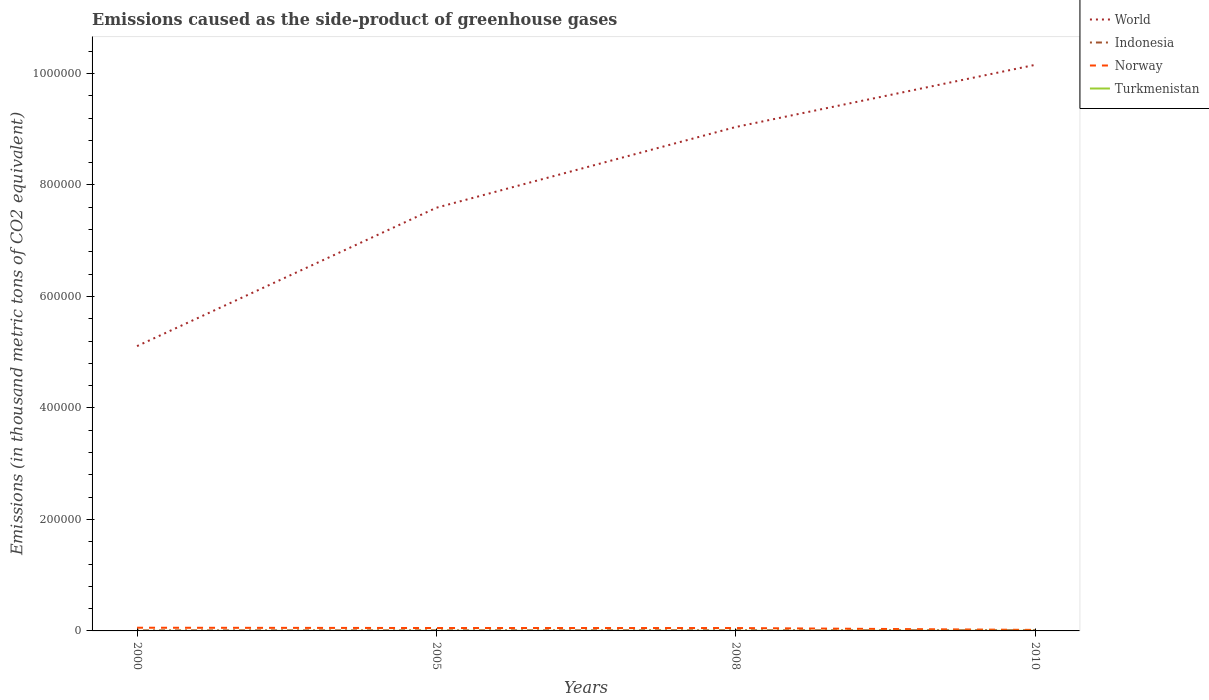Does the line corresponding to Norway intersect with the line corresponding to Turkmenistan?
Offer a very short reply. No. Is the number of lines equal to the number of legend labels?
Provide a short and direct response. Yes. Across all years, what is the maximum emissions caused as the side-product of greenhouse gases in Indonesia?
Make the answer very short. 997.4. In which year was the emissions caused as the side-product of greenhouse gases in Indonesia maximum?
Your response must be concise. 2000. What is the total emissions caused as the side-product of greenhouse gases in Norway in the graph?
Provide a short and direct response. 524.3. What is the difference between the highest and the second highest emissions caused as the side-product of greenhouse gases in Turkmenistan?
Give a very brief answer. 128.1. What is the difference between the highest and the lowest emissions caused as the side-product of greenhouse gases in World?
Your answer should be compact. 2. Is the emissions caused as the side-product of greenhouse gases in World strictly greater than the emissions caused as the side-product of greenhouse gases in Norway over the years?
Make the answer very short. No. Where does the legend appear in the graph?
Your answer should be very brief. Top right. What is the title of the graph?
Your response must be concise. Emissions caused as the side-product of greenhouse gases. What is the label or title of the X-axis?
Provide a succinct answer. Years. What is the label or title of the Y-axis?
Your response must be concise. Emissions (in thousand metric tons of CO2 equivalent). What is the Emissions (in thousand metric tons of CO2 equivalent) of World in 2000?
Offer a terse response. 5.11e+05. What is the Emissions (in thousand metric tons of CO2 equivalent) in Indonesia in 2000?
Your answer should be compact. 997.4. What is the Emissions (in thousand metric tons of CO2 equivalent) in Norway in 2000?
Offer a very short reply. 5742.8. What is the Emissions (in thousand metric tons of CO2 equivalent) of Turkmenistan in 2000?
Your answer should be compact. 10.9. What is the Emissions (in thousand metric tons of CO2 equivalent) of World in 2005?
Your answer should be compact. 7.59e+05. What is the Emissions (in thousand metric tons of CO2 equivalent) of Indonesia in 2005?
Provide a succinct answer. 1020.5. What is the Emissions (in thousand metric tons of CO2 equivalent) in Norway in 2005?
Offer a very short reply. 5218.5. What is the Emissions (in thousand metric tons of CO2 equivalent) of Turkmenistan in 2005?
Ensure brevity in your answer.  72.9. What is the Emissions (in thousand metric tons of CO2 equivalent) of World in 2008?
Your answer should be very brief. 9.04e+05. What is the Emissions (in thousand metric tons of CO2 equivalent) of Indonesia in 2008?
Offer a terse response. 1146. What is the Emissions (in thousand metric tons of CO2 equivalent) in Norway in 2008?
Offer a terse response. 5179.9. What is the Emissions (in thousand metric tons of CO2 equivalent) in Turkmenistan in 2008?
Your answer should be compact. 112.2. What is the Emissions (in thousand metric tons of CO2 equivalent) of World in 2010?
Keep it short and to the point. 1.02e+06. What is the Emissions (in thousand metric tons of CO2 equivalent) in Indonesia in 2010?
Ensure brevity in your answer.  1241. What is the Emissions (in thousand metric tons of CO2 equivalent) of Norway in 2010?
Your answer should be very brief. 1823. What is the Emissions (in thousand metric tons of CO2 equivalent) in Turkmenistan in 2010?
Your answer should be compact. 139. Across all years, what is the maximum Emissions (in thousand metric tons of CO2 equivalent) in World?
Give a very brief answer. 1.02e+06. Across all years, what is the maximum Emissions (in thousand metric tons of CO2 equivalent) in Indonesia?
Offer a terse response. 1241. Across all years, what is the maximum Emissions (in thousand metric tons of CO2 equivalent) of Norway?
Your response must be concise. 5742.8. Across all years, what is the maximum Emissions (in thousand metric tons of CO2 equivalent) in Turkmenistan?
Provide a short and direct response. 139. Across all years, what is the minimum Emissions (in thousand metric tons of CO2 equivalent) of World?
Keep it short and to the point. 5.11e+05. Across all years, what is the minimum Emissions (in thousand metric tons of CO2 equivalent) of Indonesia?
Provide a succinct answer. 997.4. Across all years, what is the minimum Emissions (in thousand metric tons of CO2 equivalent) in Norway?
Your answer should be very brief. 1823. Across all years, what is the minimum Emissions (in thousand metric tons of CO2 equivalent) in Turkmenistan?
Provide a succinct answer. 10.9. What is the total Emissions (in thousand metric tons of CO2 equivalent) of World in the graph?
Offer a very short reply. 3.19e+06. What is the total Emissions (in thousand metric tons of CO2 equivalent) in Indonesia in the graph?
Keep it short and to the point. 4404.9. What is the total Emissions (in thousand metric tons of CO2 equivalent) in Norway in the graph?
Provide a succinct answer. 1.80e+04. What is the total Emissions (in thousand metric tons of CO2 equivalent) of Turkmenistan in the graph?
Keep it short and to the point. 335. What is the difference between the Emissions (in thousand metric tons of CO2 equivalent) of World in 2000 and that in 2005?
Provide a short and direct response. -2.48e+05. What is the difference between the Emissions (in thousand metric tons of CO2 equivalent) in Indonesia in 2000 and that in 2005?
Offer a very short reply. -23.1. What is the difference between the Emissions (in thousand metric tons of CO2 equivalent) in Norway in 2000 and that in 2005?
Provide a short and direct response. 524.3. What is the difference between the Emissions (in thousand metric tons of CO2 equivalent) in Turkmenistan in 2000 and that in 2005?
Make the answer very short. -62. What is the difference between the Emissions (in thousand metric tons of CO2 equivalent) of World in 2000 and that in 2008?
Give a very brief answer. -3.93e+05. What is the difference between the Emissions (in thousand metric tons of CO2 equivalent) of Indonesia in 2000 and that in 2008?
Your response must be concise. -148.6. What is the difference between the Emissions (in thousand metric tons of CO2 equivalent) in Norway in 2000 and that in 2008?
Offer a terse response. 562.9. What is the difference between the Emissions (in thousand metric tons of CO2 equivalent) in Turkmenistan in 2000 and that in 2008?
Give a very brief answer. -101.3. What is the difference between the Emissions (in thousand metric tons of CO2 equivalent) of World in 2000 and that in 2010?
Make the answer very short. -5.05e+05. What is the difference between the Emissions (in thousand metric tons of CO2 equivalent) in Indonesia in 2000 and that in 2010?
Provide a short and direct response. -243.6. What is the difference between the Emissions (in thousand metric tons of CO2 equivalent) in Norway in 2000 and that in 2010?
Give a very brief answer. 3919.8. What is the difference between the Emissions (in thousand metric tons of CO2 equivalent) of Turkmenistan in 2000 and that in 2010?
Your response must be concise. -128.1. What is the difference between the Emissions (in thousand metric tons of CO2 equivalent) in World in 2005 and that in 2008?
Offer a very short reply. -1.45e+05. What is the difference between the Emissions (in thousand metric tons of CO2 equivalent) of Indonesia in 2005 and that in 2008?
Give a very brief answer. -125.5. What is the difference between the Emissions (in thousand metric tons of CO2 equivalent) of Norway in 2005 and that in 2008?
Ensure brevity in your answer.  38.6. What is the difference between the Emissions (in thousand metric tons of CO2 equivalent) in Turkmenistan in 2005 and that in 2008?
Make the answer very short. -39.3. What is the difference between the Emissions (in thousand metric tons of CO2 equivalent) in World in 2005 and that in 2010?
Give a very brief answer. -2.56e+05. What is the difference between the Emissions (in thousand metric tons of CO2 equivalent) of Indonesia in 2005 and that in 2010?
Offer a terse response. -220.5. What is the difference between the Emissions (in thousand metric tons of CO2 equivalent) of Norway in 2005 and that in 2010?
Ensure brevity in your answer.  3395.5. What is the difference between the Emissions (in thousand metric tons of CO2 equivalent) of Turkmenistan in 2005 and that in 2010?
Ensure brevity in your answer.  -66.1. What is the difference between the Emissions (in thousand metric tons of CO2 equivalent) in World in 2008 and that in 2010?
Provide a short and direct response. -1.11e+05. What is the difference between the Emissions (in thousand metric tons of CO2 equivalent) of Indonesia in 2008 and that in 2010?
Your answer should be compact. -95. What is the difference between the Emissions (in thousand metric tons of CO2 equivalent) of Norway in 2008 and that in 2010?
Your answer should be compact. 3356.9. What is the difference between the Emissions (in thousand metric tons of CO2 equivalent) in Turkmenistan in 2008 and that in 2010?
Provide a succinct answer. -26.8. What is the difference between the Emissions (in thousand metric tons of CO2 equivalent) in World in 2000 and the Emissions (in thousand metric tons of CO2 equivalent) in Indonesia in 2005?
Offer a very short reply. 5.10e+05. What is the difference between the Emissions (in thousand metric tons of CO2 equivalent) of World in 2000 and the Emissions (in thousand metric tons of CO2 equivalent) of Norway in 2005?
Provide a succinct answer. 5.06e+05. What is the difference between the Emissions (in thousand metric tons of CO2 equivalent) of World in 2000 and the Emissions (in thousand metric tons of CO2 equivalent) of Turkmenistan in 2005?
Offer a very short reply. 5.11e+05. What is the difference between the Emissions (in thousand metric tons of CO2 equivalent) in Indonesia in 2000 and the Emissions (in thousand metric tons of CO2 equivalent) in Norway in 2005?
Ensure brevity in your answer.  -4221.1. What is the difference between the Emissions (in thousand metric tons of CO2 equivalent) of Indonesia in 2000 and the Emissions (in thousand metric tons of CO2 equivalent) of Turkmenistan in 2005?
Offer a terse response. 924.5. What is the difference between the Emissions (in thousand metric tons of CO2 equivalent) of Norway in 2000 and the Emissions (in thousand metric tons of CO2 equivalent) of Turkmenistan in 2005?
Keep it short and to the point. 5669.9. What is the difference between the Emissions (in thousand metric tons of CO2 equivalent) in World in 2000 and the Emissions (in thousand metric tons of CO2 equivalent) in Indonesia in 2008?
Make the answer very short. 5.10e+05. What is the difference between the Emissions (in thousand metric tons of CO2 equivalent) of World in 2000 and the Emissions (in thousand metric tons of CO2 equivalent) of Norway in 2008?
Give a very brief answer. 5.06e+05. What is the difference between the Emissions (in thousand metric tons of CO2 equivalent) in World in 2000 and the Emissions (in thousand metric tons of CO2 equivalent) in Turkmenistan in 2008?
Offer a very short reply. 5.11e+05. What is the difference between the Emissions (in thousand metric tons of CO2 equivalent) of Indonesia in 2000 and the Emissions (in thousand metric tons of CO2 equivalent) of Norway in 2008?
Give a very brief answer. -4182.5. What is the difference between the Emissions (in thousand metric tons of CO2 equivalent) in Indonesia in 2000 and the Emissions (in thousand metric tons of CO2 equivalent) in Turkmenistan in 2008?
Offer a terse response. 885.2. What is the difference between the Emissions (in thousand metric tons of CO2 equivalent) of Norway in 2000 and the Emissions (in thousand metric tons of CO2 equivalent) of Turkmenistan in 2008?
Ensure brevity in your answer.  5630.6. What is the difference between the Emissions (in thousand metric tons of CO2 equivalent) in World in 2000 and the Emissions (in thousand metric tons of CO2 equivalent) in Indonesia in 2010?
Give a very brief answer. 5.10e+05. What is the difference between the Emissions (in thousand metric tons of CO2 equivalent) of World in 2000 and the Emissions (in thousand metric tons of CO2 equivalent) of Norway in 2010?
Make the answer very short. 5.09e+05. What is the difference between the Emissions (in thousand metric tons of CO2 equivalent) of World in 2000 and the Emissions (in thousand metric tons of CO2 equivalent) of Turkmenistan in 2010?
Ensure brevity in your answer.  5.11e+05. What is the difference between the Emissions (in thousand metric tons of CO2 equivalent) of Indonesia in 2000 and the Emissions (in thousand metric tons of CO2 equivalent) of Norway in 2010?
Ensure brevity in your answer.  -825.6. What is the difference between the Emissions (in thousand metric tons of CO2 equivalent) of Indonesia in 2000 and the Emissions (in thousand metric tons of CO2 equivalent) of Turkmenistan in 2010?
Ensure brevity in your answer.  858.4. What is the difference between the Emissions (in thousand metric tons of CO2 equivalent) in Norway in 2000 and the Emissions (in thousand metric tons of CO2 equivalent) in Turkmenistan in 2010?
Offer a terse response. 5603.8. What is the difference between the Emissions (in thousand metric tons of CO2 equivalent) of World in 2005 and the Emissions (in thousand metric tons of CO2 equivalent) of Indonesia in 2008?
Your answer should be very brief. 7.58e+05. What is the difference between the Emissions (in thousand metric tons of CO2 equivalent) of World in 2005 and the Emissions (in thousand metric tons of CO2 equivalent) of Norway in 2008?
Your answer should be compact. 7.54e+05. What is the difference between the Emissions (in thousand metric tons of CO2 equivalent) in World in 2005 and the Emissions (in thousand metric tons of CO2 equivalent) in Turkmenistan in 2008?
Keep it short and to the point. 7.59e+05. What is the difference between the Emissions (in thousand metric tons of CO2 equivalent) of Indonesia in 2005 and the Emissions (in thousand metric tons of CO2 equivalent) of Norway in 2008?
Give a very brief answer. -4159.4. What is the difference between the Emissions (in thousand metric tons of CO2 equivalent) in Indonesia in 2005 and the Emissions (in thousand metric tons of CO2 equivalent) in Turkmenistan in 2008?
Offer a terse response. 908.3. What is the difference between the Emissions (in thousand metric tons of CO2 equivalent) in Norway in 2005 and the Emissions (in thousand metric tons of CO2 equivalent) in Turkmenistan in 2008?
Your answer should be very brief. 5106.3. What is the difference between the Emissions (in thousand metric tons of CO2 equivalent) of World in 2005 and the Emissions (in thousand metric tons of CO2 equivalent) of Indonesia in 2010?
Make the answer very short. 7.58e+05. What is the difference between the Emissions (in thousand metric tons of CO2 equivalent) in World in 2005 and the Emissions (in thousand metric tons of CO2 equivalent) in Norway in 2010?
Offer a very short reply. 7.57e+05. What is the difference between the Emissions (in thousand metric tons of CO2 equivalent) of World in 2005 and the Emissions (in thousand metric tons of CO2 equivalent) of Turkmenistan in 2010?
Your response must be concise. 7.59e+05. What is the difference between the Emissions (in thousand metric tons of CO2 equivalent) in Indonesia in 2005 and the Emissions (in thousand metric tons of CO2 equivalent) in Norway in 2010?
Offer a very short reply. -802.5. What is the difference between the Emissions (in thousand metric tons of CO2 equivalent) in Indonesia in 2005 and the Emissions (in thousand metric tons of CO2 equivalent) in Turkmenistan in 2010?
Make the answer very short. 881.5. What is the difference between the Emissions (in thousand metric tons of CO2 equivalent) in Norway in 2005 and the Emissions (in thousand metric tons of CO2 equivalent) in Turkmenistan in 2010?
Your response must be concise. 5079.5. What is the difference between the Emissions (in thousand metric tons of CO2 equivalent) in World in 2008 and the Emissions (in thousand metric tons of CO2 equivalent) in Indonesia in 2010?
Offer a very short reply. 9.03e+05. What is the difference between the Emissions (in thousand metric tons of CO2 equivalent) in World in 2008 and the Emissions (in thousand metric tons of CO2 equivalent) in Norway in 2010?
Offer a terse response. 9.02e+05. What is the difference between the Emissions (in thousand metric tons of CO2 equivalent) in World in 2008 and the Emissions (in thousand metric tons of CO2 equivalent) in Turkmenistan in 2010?
Ensure brevity in your answer.  9.04e+05. What is the difference between the Emissions (in thousand metric tons of CO2 equivalent) in Indonesia in 2008 and the Emissions (in thousand metric tons of CO2 equivalent) in Norway in 2010?
Your answer should be very brief. -677. What is the difference between the Emissions (in thousand metric tons of CO2 equivalent) in Indonesia in 2008 and the Emissions (in thousand metric tons of CO2 equivalent) in Turkmenistan in 2010?
Give a very brief answer. 1007. What is the difference between the Emissions (in thousand metric tons of CO2 equivalent) in Norway in 2008 and the Emissions (in thousand metric tons of CO2 equivalent) in Turkmenistan in 2010?
Your answer should be very brief. 5040.9. What is the average Emissions (in thousand metric tons of CO2 equivalent) of World per year?
Your answer should be very brief. 7.97e+05. What is the average Emissions (in thousand metric tons of CO2 equivalent) of Indonesia per year?
Make the answer very short. 1101.22. What is the average Emissions (in thousand metric tons of CO2 equivalent) in Norway per year?
Offer a terse response. 4491.05. What is the average Emissions (in thousand metric tons of CO2 equivalent) of Turkmenistan per year?
Keep it short and to the point. 83.75. In the year 2000, what is the difference between the Emissions (in thousand metric tons of CO2 equivalent) of World and Emissions (in thousand metric tons of CO2 equivalent) of Indonesia?
Ensure brevity in your answer.  5.10e+05. In the year 2000, what is the difference between the Emissions (in thousand metric tons of CO2 equivalent) of World and Emissions (in thousand metric tons of CO2 equivalent) of Norway?
Your response must be concise. 5.05e+05. In the year 2000, what is the difference between the Emissions (in thousand metric tons of CO2 equivalent) in World and Emissions (in thousand metric tons of CO2 equivalent) in Turkmenistan?
Give a very brief answer. 5.11e+05. In the year 2000, what is the difference between the Emissions (in thousand metric tons of CO2 equivalent) of Indonesia and Emissions (in thousand metric tons of CO2 equivalent) of Norway?
Provide a succinct answer. -4745.4. In the year 2000, what is the difference between the Emissions (in thousand metric tons of CO2 equivalent) of Indonesia and Emissions (in thousand metric tons of CO2 equivalent) of Turkmenistan?
Ensure brevity in your answer.  986.5. In the year 2000, what is the difference between the Emissions (in thousand metric tons of CO2 equivalent) of Norway and Emissions (in thousand metric tons of CO2 equivalent) of Turkmenistan?
Offer a terse response. 5731.9. In the year 2005, what is the difference between the Emissions (in thousand metric tons of CO2 equivalent) in World and Emissions (in thousand metric tons of CO2 equivalent) in Indonesia?
Ensure brevity in your answer.  7.58e+05. In the year 2005, what is the difference between the Emissions (in thousand metric tons of CO2 equivalent) of World and Emissions (in thousand metric tons of CO2 equivalent) of Norway?
Your response must be concise. 7.54e+05. In the year 2005, what is the difference between the Emissions (in thousand metric tons of CO2 equivalent) in World and Emissions (in thousand metric tons of CO2 equivalent) in Turkmenistan?
Provide a short and direct response. 7.59e+05. In the year 2005, what is the difference between the Emissions (in thousand metric tons of CO2 equivalent) of Indonesia and Emissions (in thousand metric tons of CO2 equivalent) of Norway?
Your answer should be very brief. -4198. In the year 2005, what is the difference between the Emissions (in thousand metric tons of CO2 equivalent) of Indonesia and Emissions (in thousand metric tons of CO2 equivalent) of Turkmenistan?
Ensure brevity in your answer.  947.6. In the year 2005, what is the difference between the Emissions (in thousand metric tons of CO2 equivalent) of Norway and Emissions (in thousand metric tons of CO2 equivalent) of Turkmenistan?
Your answer should be compact. 5145.6. In the year 2008, what is the difference between the Emissions (in thousand metric tons of CO2 equivalent) in World and Emissions (in thousand metric tons of CO2 equivalent) in Indonesia?
Give a very brief answer. 9.03e+05. In the year 2008, what is the difference between the Emissions (in thousand metric tons of CO2 equivalent) in World and Emissions (in thousand metric tons of CO2 equivalent) in Norway?
Make the answer very short. 8.99e+05. In the year 2008, what is the difference between the Emissions (in thousand metric tons of CO2 equivalent) in World and Emissions (in thousand metric tons of CO2 equivalent) in Turkmenistan?
Provide a succinct answer. 9.04e+05. In the year 2008, what is the difference between the Emissions (in thousand metric tons of CO2 equivalent) of Indonesia and Emissions (in thousand metric tons of CO2 equivalent) of Norway?
Offer a very short reply. -4033.9. In the year 2008, what is the difference between the Emissions (in thousand metric tons of CO2 equivalent) in Indonesia and Emissions (in thousand metric tons of CO2 equivalent) in Turkmenistan?
Your answer should be compact. 1033.8. In the year 2008, what is the difference between the Emissions (in thousand metric tons of CO2 equivalent) in Norway and Emissions (in thousand metric tons of CO2 equivalent) in Turkmenistan?
Offer a terse response. 5067.7. In the year 2010, what is the difference between the Emissions (in thousand metric tons of CO2 equivalent) of World and Emissions (in thousand metric tons of CO2 equivalent) of Indonesia?
Ensure brevity in your answer.  1.01e+06. In the year 2010, what is the difference between the Emissions (in thousand metric tons of CO2 equivalent) of World and Emissions (in thousand metric tons of CO2 equivalent) of Norway?
Your response must be concise. 1.01e+06. In the year 2010, what is the difference between the Emissions (in thousand metric tons of CO2 equivalent) in World and Emissions (in thousand metric tons of CO2 equivalent) in Turkmenistan?
Your answer should be very brief. 1.02e+06. In the year 2010, what is the difference between the Emissions (in thousand metric tons of CO2 equivalent) of Indonesia and Emissions (in thousand metric tons of CO2 equivalent) of Norway?
Provide a short and direct response. -582. In the year 2010, what is the difference between the Emissions (in thousand metric tons of CO2 equivalent) in Indonesia and Emissions (in thousand metric tons of CO2 equivalent) in Turkmenistan?
Provide a short and direct response. 1102. In the year 2010, what is the difference between the Emissions (in thousand metric tons of CO2 equivalent) of Norway and Emissions (in thousand metric tons of CO2 equivalent) of Turkmenistan?
Provide a succinct answer. 1684. What is the ratio of the Emissions (in thousand metric tons of CO2 equivalent) in World in 2000 to that in 2005?
Your answer should be very brief. 0.67. What is the ratio of the Emissions (in thousand metric tons of CO2 equivalent) in Indonesia in 2000 to that in 2005?
Keep it short and to the point. 0.98. What is the ratio of the Emissions (in thousand metric tons of CO2 equivalent) of Norway in 2000 to that in 2005?
Keep it short and to the point. 1.1. What is the ratio of the Emissions (in thousand metric tons of CO2 equivalent) in Turkmenistan in 2000 to that in 2005?
Give a very brief answer. 0.15. What is the ratio of the Emissions (in thousand metric tons of CO2 equivalent) of World in 2000 to that in 2008?
Your response must be concise. 0.57. What is the ratio of the Emissions (in thousand metric tons of CO2 equivalent) in Indonesia in 2000 to that in 2008?
Your response must be concise. 0.87. What is the ratio of the Emissions (in thousand metric tons of CO2 equivalent) in Norway in 2000 to that in 2008?
Provide a short and direct response. 1.11. What is the ratio of the Emissions (in thousand metric tons of CO2 equivalent) of Turkmenistan in 2000 to that in 2008?
Your answer should be very brief. 0.1. What is the ratio of the Emissions (in thousand metric tons of CO2 equivalent) of World in 2000 to that in 2010?
Keep it short and to the point. 0.5. What is the ratio of the Emissions (in thousand metric tons of CO2 equivalent) of Indonesia in 2000 to that in 2010?
Provide a succinct answer. 0.8. What is the ratio of the Emissions (in thousand metric tons of CO2 equivalent) in Norway in 2000 to that in 2010?
Make the answer very short. 3.15. What is the ratio of the Emissions (in thousand metric tons of CO2 equivalent) in Turkmenistan in 2000 to that in 2010?
Offer a very short reply. 0.08. What is the ratio of the Emissions (in thousand metric tons of CO2 equivalent) of World in 2005 to that in 2008?
Your answer should be very brief. 0.84. What is the ratio of the Emissions (in thousand metric tons of CO2 equivalent) in Indonesia in 2005 to that in 2008?
Ensure brevity in your answer.  0.89. What is the ratio of the Emissions (in thousand metric tons of CO2 equivalent) of Norway in 2005 to that in 2008?
Your response must be concise. 1.01. What is the ratio of the Emissions (in thousand metric tons of CO2 equivalent) in Turkmenistan in 2005 to that in 2008?
Offer a very short reply. 0.65. What is the ratio of the Emissions (in thousand metric tons of CO2 equivalent) in World in 2005 to that in 2010?
Ensure brevity in your answer.  0.75. What is the ratio of the Emissions (in thousand metric tons of CO2 equivalent) of Indonesia in 2005 to that in 2010?
Provide a short and direct response. 0.82. What is the ratio of the Emissions (in thousand metric tons of CO2 equivalent) of Norway in 2005 to that in 2010?
Your answer should be compact. 2.86. What is the ratio of the Emissions (in thousand metric tons of CO2 equivalent) in Turkmenistan in 2005 to that in 2010?
Give a very brief answer. 0.52. What is the ratio of the Emissions (in thousand metric tons of CO2 equivalent) of World in 2008 to that in 2010?
Your answer should be compact. 0.89. What is the ratio of the Emissions (in thousand metric tons of CO2 equivalent) of Indonesia in 2008 to that in 2010?
Your response must be concise. 0.92. What is the ratio of the Emissions (in thousand metric tons of CO2 equivalent) of Norway in 2008 to that in 2010?
Your answer should be very brief. 2.84. What is the ratio of the Emissions (in thousand metric tons of CO2 equivalent) in Turkmenistan in 2008 to that in 2010?
Keep it short and to the point. 0.81. What is the difference between the highest and the second highest Emissions (in thousand metric tons of CO2 equivalent) of World?
Your answer should be compact. 1.11e+05. What is the difference between the highest and the second highest Emissions (in thousand metric tons of CO2 equivalent) of Indonesia?
Provide a short and direct response. 95. What is the difference between the highest and the second highest Emissions (in thousand metric tons of CO2 equivalent) in Norway?
Your answer should be very brief. 524.3. What is the difference between the highest and the second highest Emissions (in thousand metric tons of CO2 equivalent) in Turkmenistan?
Offer a terse response. 26.8. What is the difference between the highest and the lowest Emissions (in thousand metric tons of CO2 equivalent) of World?
Ensure brevity in your answer.  5.05e+05. What is the difference between the highest and the lowest Emissions (in thousand metric tons of CO2 equivalent) in Indonesia?
Your response must be concise. 243.6. What is the difference between the highest and the lowest Emissions (in thousand metric tons of CO2 equivalent) in Norway?
Offer a very short reply. 3919.8. What is the difference between the highest and the lowest Emissions (in thousand metric tons of CO2 equivalent) in Turkmenistan?
Give a very brief answer. 128.1. 